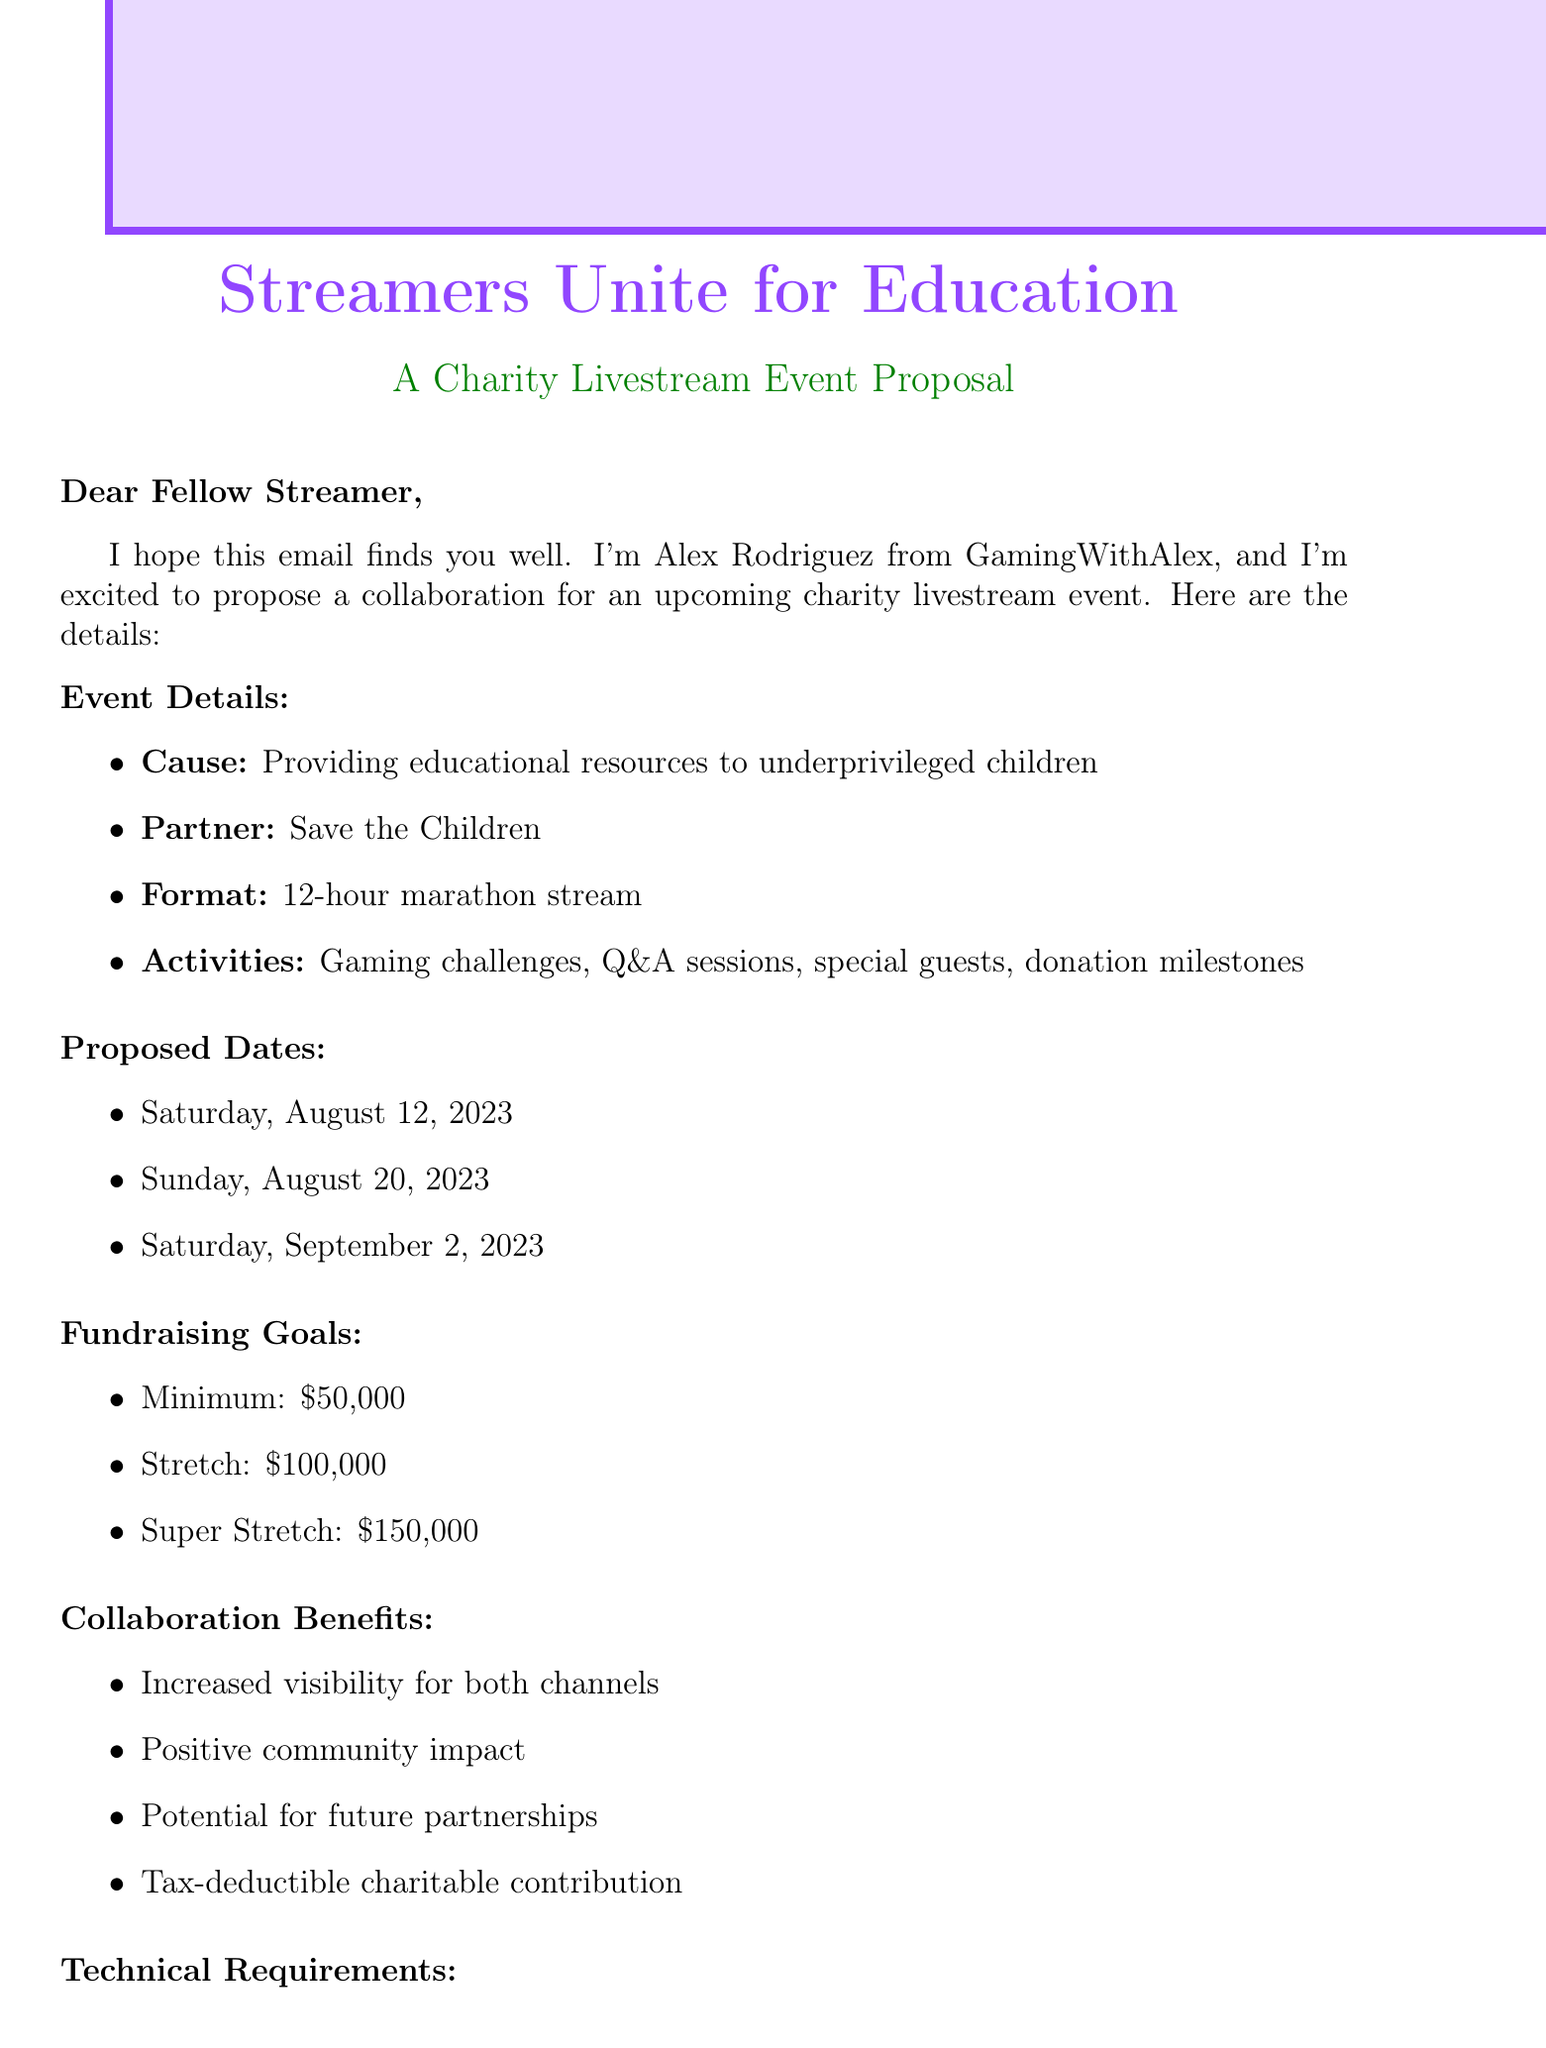What is the name of the event? The event name is explicitly mentioned in the document.
Answer: Streamers Unite for Education What is the cause of the charity livestream? The document states the purpose of the charity livestream event clearly.
Answer: Providing educational resources to underprivileged children Who is the partner organization for the event? The document directly references the partner organization involved in the event.
Answer: Save the Children What is the minimum fundraising goal? The document specifies the different fundraising goals set for the event.
Answer: 50000 What are the proposed dates for the event? The document lists three possible dates for the event.
Answer: Saturday, August 12, 2023 What is one of the collaboration benefits? The document outlines several benefits for both streamers involved in the collaboration.
Answer: Increased visibility for both channels What is the duration of the livestream? The document provides the length of the proposed livestream format clearly.
Answer: 12-hour marathon What platform will the livestream be on? The technical requirements section of the document specifies the platform used for the stream.
Answer: Twitch What is the next step after confirming interest? The document outlines the sequential steps to be taken after confirming interest.
Answer: Schedule a planning call What are the additional tools mentioned in the technical requirements? The document mentions tools that will be necessary for the event.
Answer: Discord for communication, Tiltify for donation tracking 